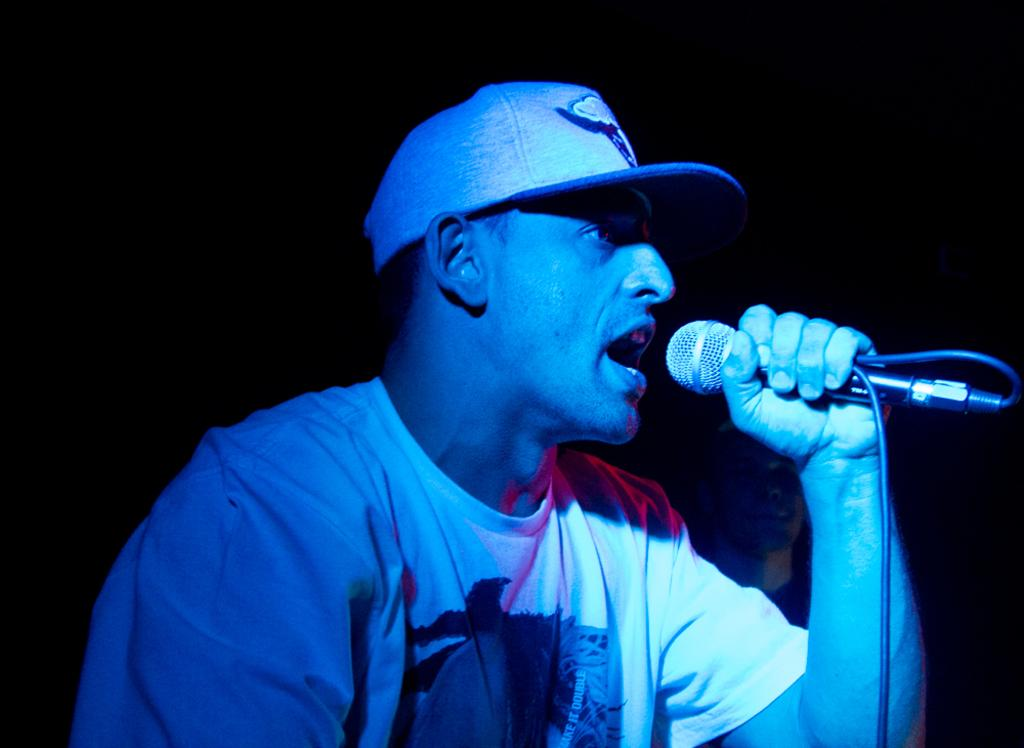What is the man in the image doing? The man is singing in the image. What object is the man holding while singing? The man is holding a microphone in his hand. Can you describe the man's attire in the image? The man is wearing a cap in the image. What can be observed about the lighting in the image? The background of the image is dark. How much pleasure does the man derive from singing in the image? The image does not provide information about the man's emotions or feelings while singing, so it is impossible to determine the amount of pleasure he derives from singing. 